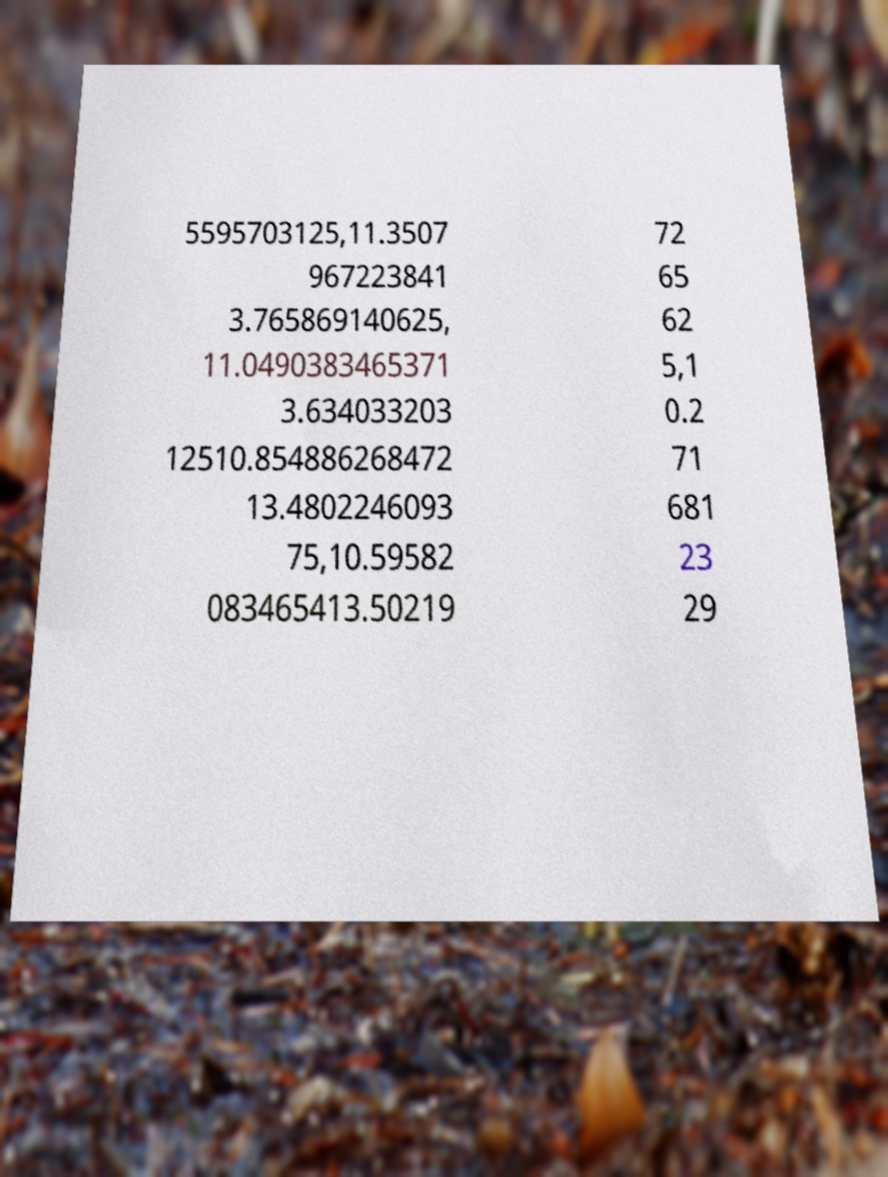Could you extract and type out the text from this image? 5595703125,11.3507 967223841 3.765869140625, 11.0490383465371 3.634033203 12510.854886268472 13.4802246093 75,10.59582 083465413.50219 72 65 62 5,1 0.2 71 681 23 29 